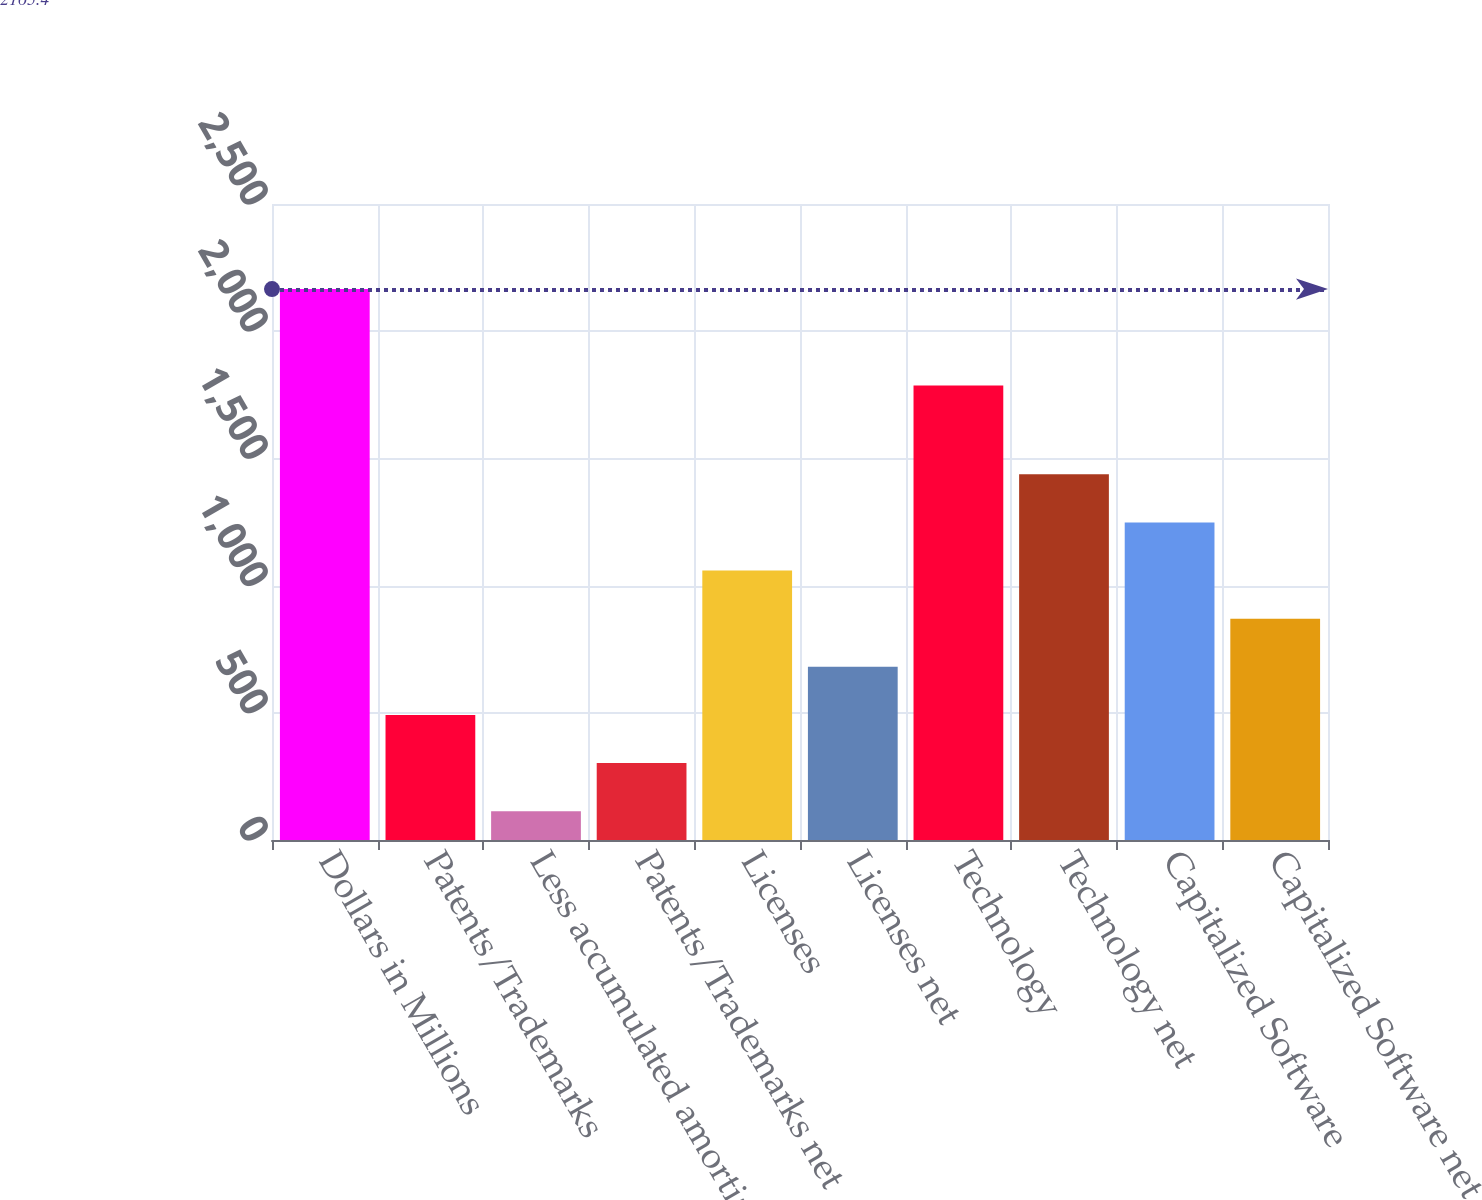<chart> <loc_0><loc_0><loc_500><loc_500><bar_chart><fcel>Dollars in Millions<fcel>Patents/Trademarks<fcel>Less accumulated amortization<fcel>Patents/Trademarks net<fcel>Licenses<fcel>Licenses net<fcel>Technology<fcel>Technology net<fcel>Capitalized Software<fcel>Capitalized Software net<nl><fcel>2165.4<fcel>491.4<fcel>113<fcel>302.2<fcel>1059<fcel>680.6<fcel>1787<fcel>1437.4<fcel>1248.2<fcel>869.8<nl></chart> 